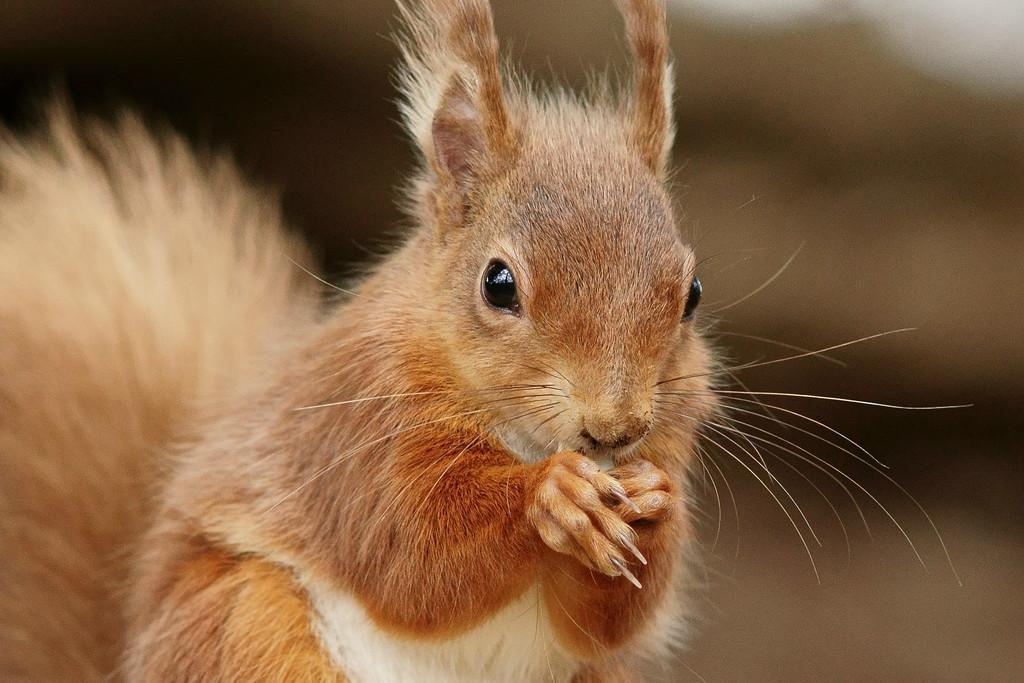What type of animal is in the image? There is a squirrel in the image. Can you describe the background of the image? The background of the image is blurred. What type of bell can be heard ringing in the image? There is no bell present in the image, and therefore no sound can be heard. 